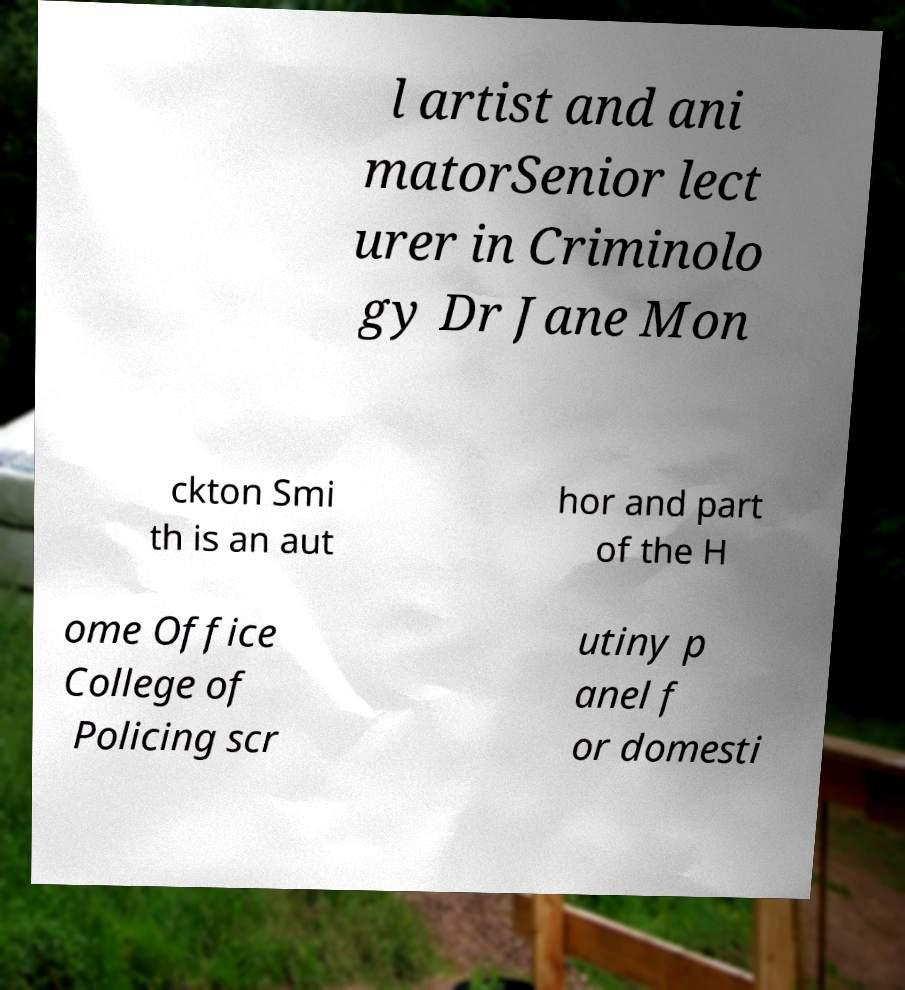I need the written content from this picture converted into text. Can you do that? l artist and ani matorSenior lect urer in Criminolo gy Dr Jane Mon ckton Smi th is an aut hor and part of the H ome Office College of Policing scr utiny p anel f or domesti 